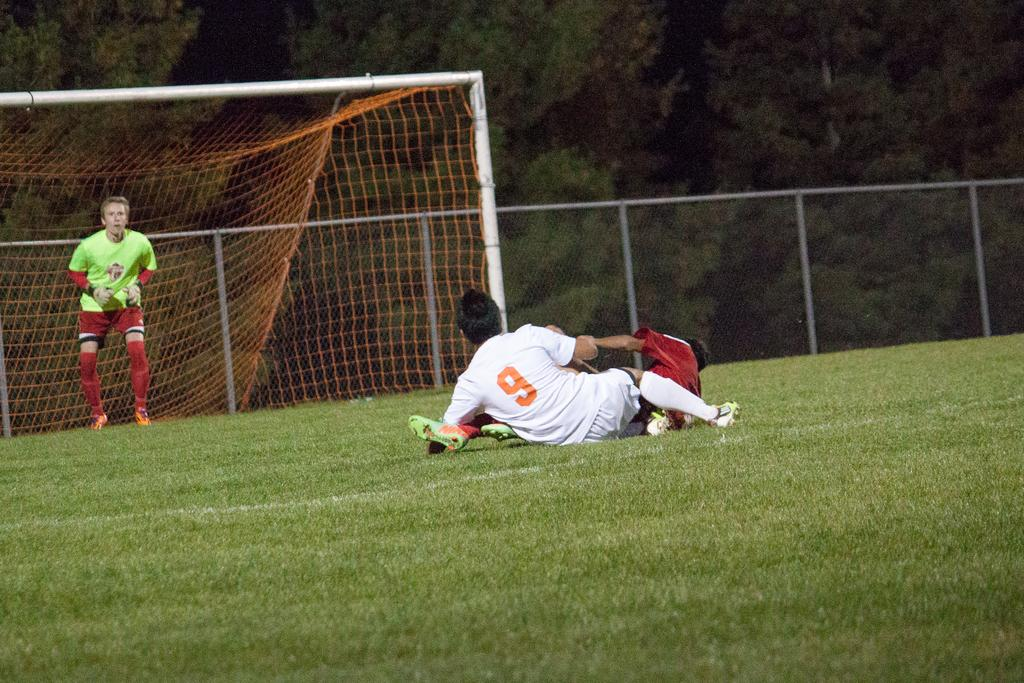Provide a one-sentence caption for the provided image. A goalie wearing a green jersey and two players including number 9 on the ground. 